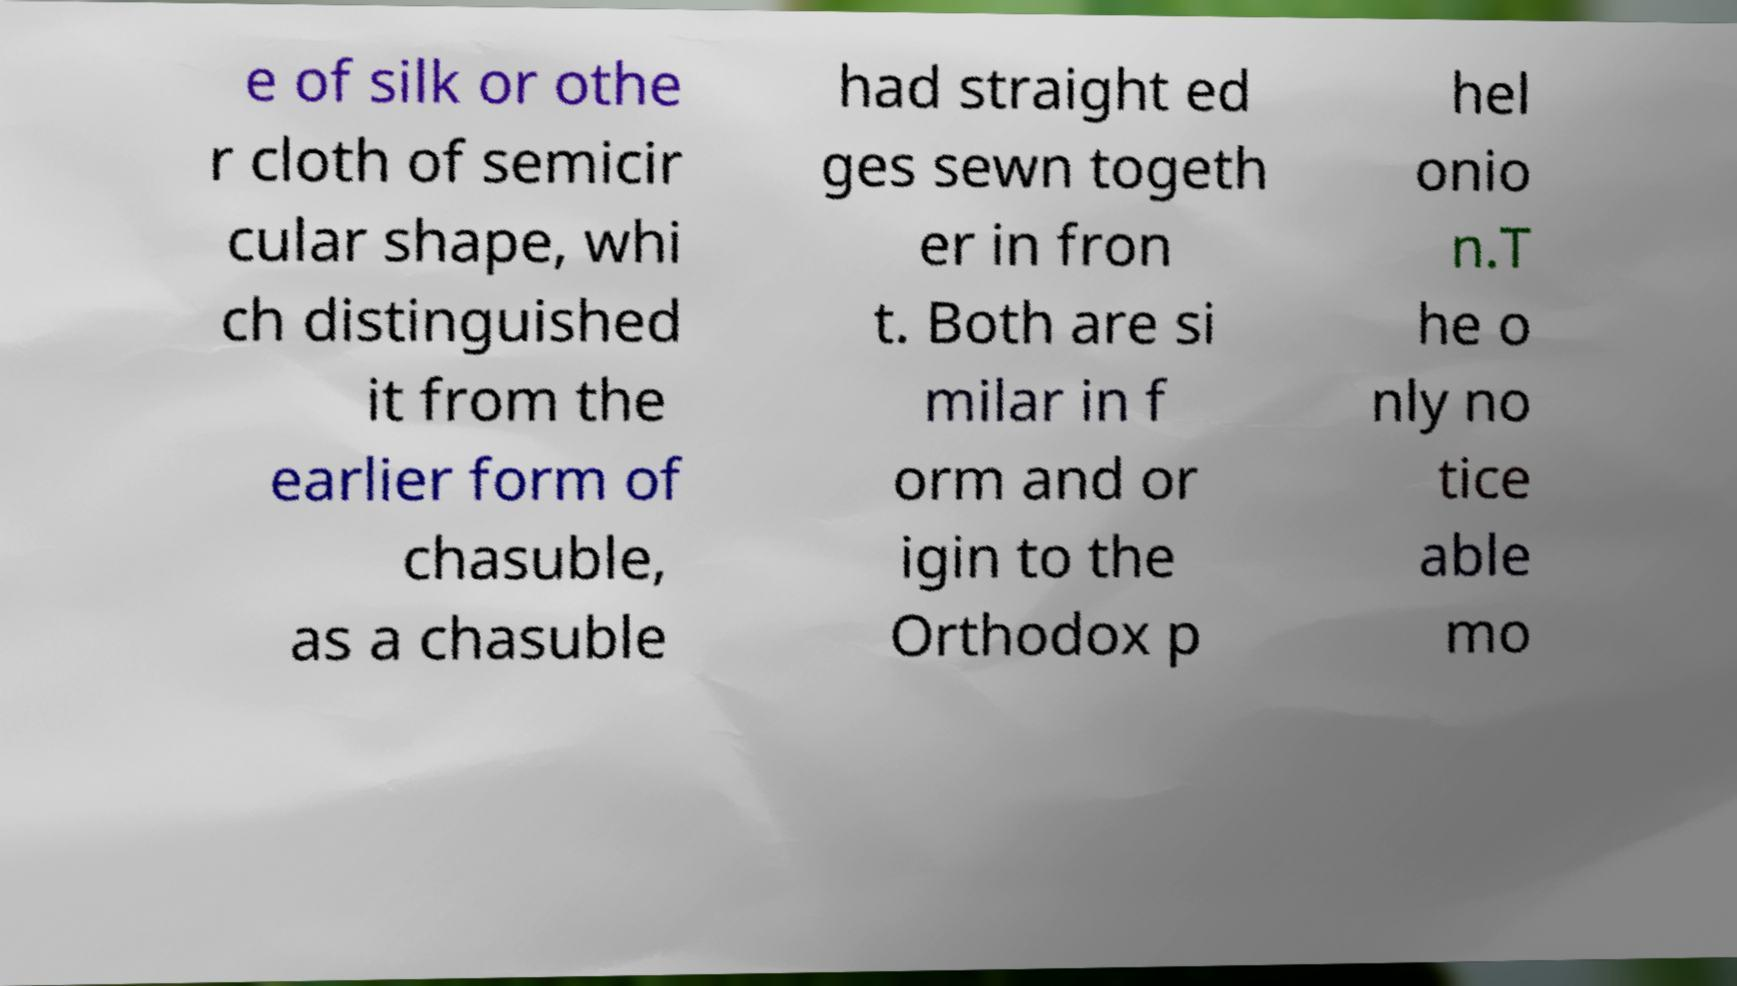For documentation purposes, I need the text within this image transcribed. Could you provide that? e of silk or othe r cloth of semicir cular shape, whi ch distinguished it from the earlier form of chasuble, as a chasuble had straight ed ges sewn togeth er in fron t. Both are si milar in f orm and or igin to the Orthodox p hel onio n.T he o nly no tice able mo 